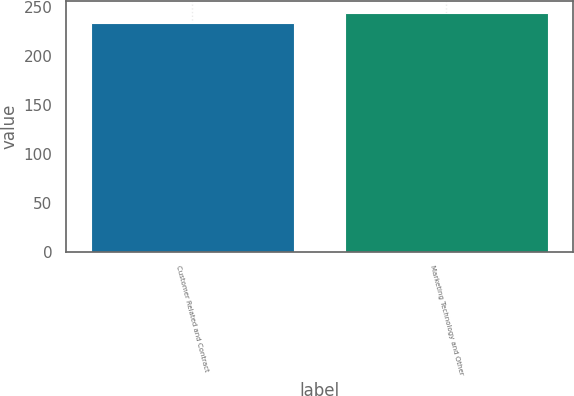Convert chart to OTSL. <chart><loc_0><loc_0><loc_500><loc_500><bar_chart><fcel>Customer Related and Contract<fcel>Marketing Technology and Other<nl><fcel>234<fcel>244<nl></chart> 